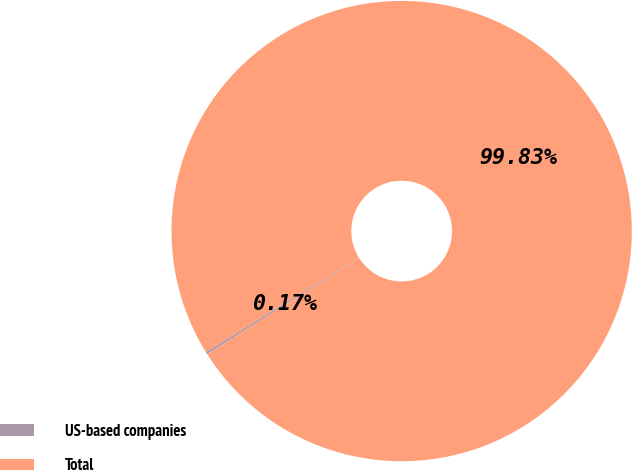<chart> <loc_0><loc_0><loc_500><loc_500><pie_chart><fcel>US-based companies<fcel>Total<nl><fcel>0.17%<fcel>99.83%<nl></chart> 